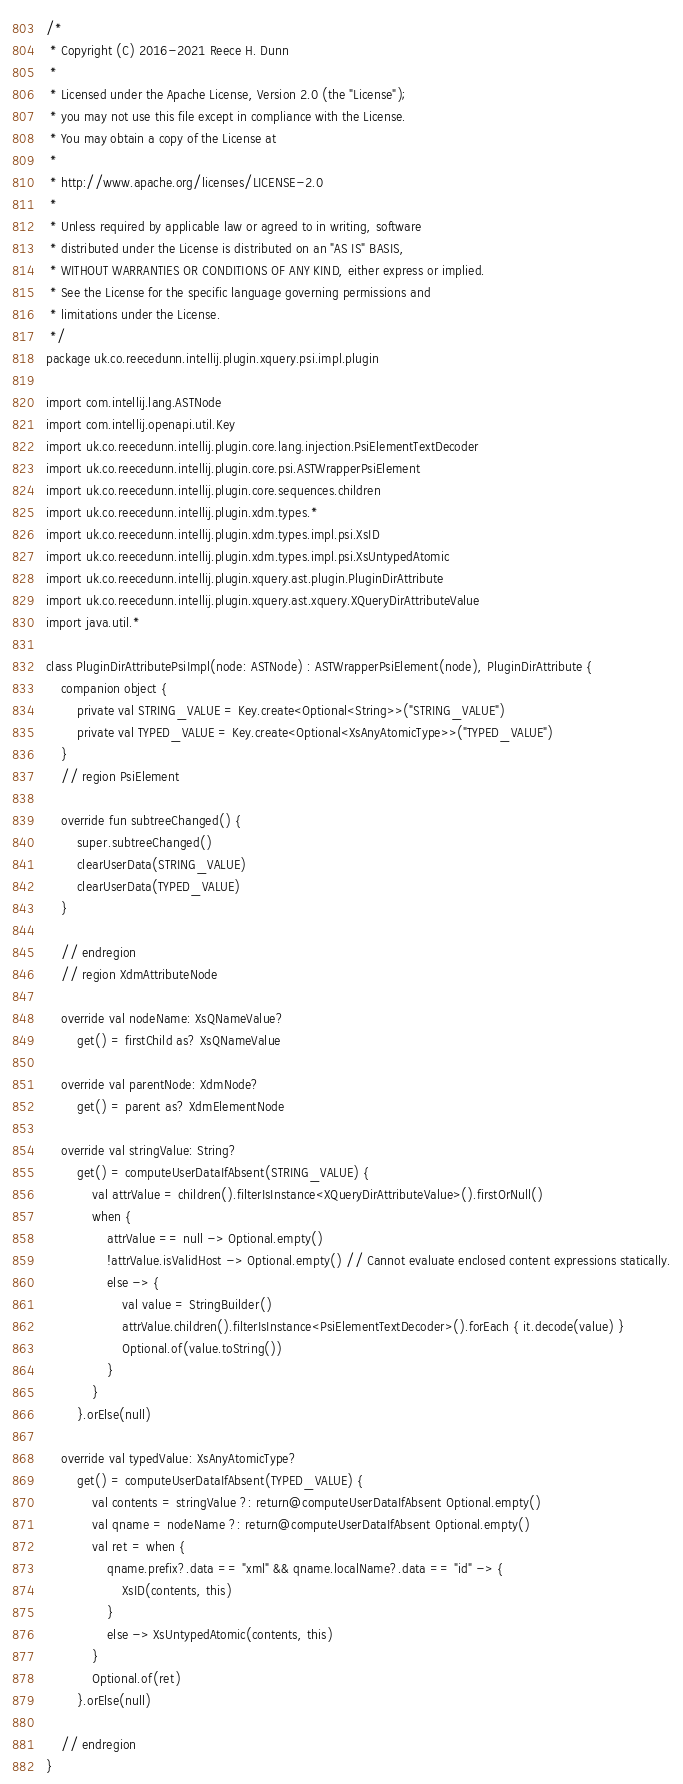<code> <loc_0><loc_0><loc_500><loc_500><_Kotlin_>/*
 * Copyright (C) 2016-2021 Reece H. Dunn
 *
 * Licensed under the Apache License, Version 2.0 (the "License");
 * you may not use this file except in compliance with the License.
 * You may obtain a copy of the License at
 *
 * http://www.apache.org/licenses/LICENSE-2.0
 *
 * Unless required by applicable law or agreed to in writing, software
 * distributed under the License is distributed on an "AS IS" BASIS,
 * WITHOUT WARRANTIES OR CONDITIONS OF ANY KIND, either express or implied.
 * See the License for the specific language governing permissions and
 * limitations under the License.
 */
package uk.co.reecedunn.intellij.plugin.xquery.psi.impl.plugin

import com.intellij.lang.ASTNode
import com.intellij.openapi.util.Key
import uk.co.reecedunn.intellij.plugin.core.lang.injection.PsiElementTextDecoder
import uk.co.reecedunn.intellij.plugin.core.psi.ASTWrapperPsiElement
import uk.co.reecedunn.intellij.plugin.core.sequences.children
import uk.co.reecedunn.intellij.plugin.xdm.types.*
import uk.co.reecedunn.intellij.plugin.xdm.types.impl.psi.XsID
import uk.co.reecedunn.intellij.plugin.xdm.types.impl.psi.XsUntypedAtomic
import uk.co.reecedunn.intellij.plugin.xquery.ast.plugin.PluginDirAttribute
import uk.co.reecedunn.intellij.plugin.xquery.ast.xquery.XQueryDirAttributeValue
import java.util.*

class PluginDirAttributePsiImpl(node: ASTNode) : ASTWrapperPsiElement(node), PluginDirAttribute {
    companion object {
        private val STRING_VALUE = Key.create<Optional<String>>("STRING_VALUE")
        private val TYPED_VALUE = Key.create<Optional<XsAnyAtomicType>>("TYPED_VALUE")
    }
    // region PsiElement

    override fun subtreeChanged() {
        super.subtreeChanged()
        clearUserData(STRING_VALUE)
        clearUserData(TYPED_VALUE)
    }

    // endregion
    // region XdmAttributeNode

    override val nodeName: XsQNameValue?
        get() = firstChild as? XsQNameValue

    override val parentNode: XdmNode?
        get() = parent as? XdmElementNode

    override val stringValue: String?
        get() = computeUserDataIfAbsent(STRING_VALUE) {
            val attrValue = children().filterIsInstance<XQueryDirAttributeValue>().firstOrNull()
            when {
                attrValue == null -> Optional.empty()
                !attrValue.isValidHost -> Optional.empty() // Cannot evaluate enclosed content expressions statically.
                else -> {
                    val value = StringBuilder()
                    attrValue.children().filterIsInstance<PsiElementTextDecoder>().forEach { it.decode(value) }
                    Optional.of(value.toString())
                }
            }
        }.orElse(null)

    override val typedValue: XsAnyAtomicType?
        get() = computeUserDataIfAbsent(TYPED_VALUE) {
            val contents = stringValue ?: return@computeUserDataIfAbsent Optional.empty()
            val qname = nodeName ?: return@computeUserDataIfAbsent Optional.empty()
            val ret = when {
                qname.prefix?.data == "xml" && qname.localName?.data == "id" -> {
                    XsID(contents, this)
                }
                else -> XsUntypedAtomic(contents, this)
            }
            Optional.of(ret)
        }.orElse(null)

    // endregion
}
</code> 